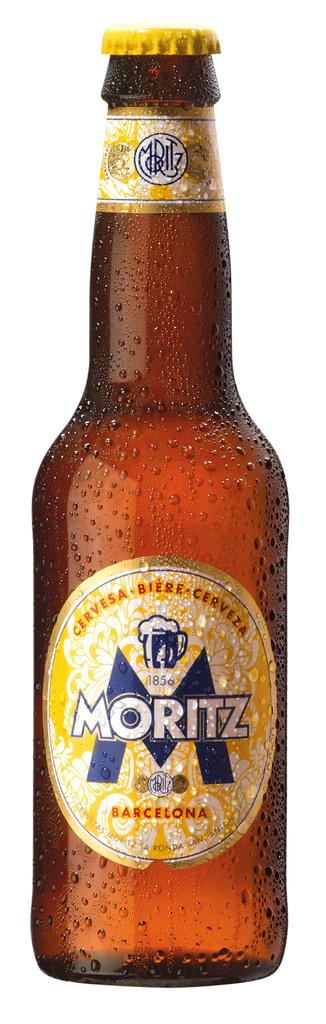What is the name of the beer?
Your response must be concise. Moritz. What is wrote below the name brand of the beer?
Offer a terse response. Barcelona. 